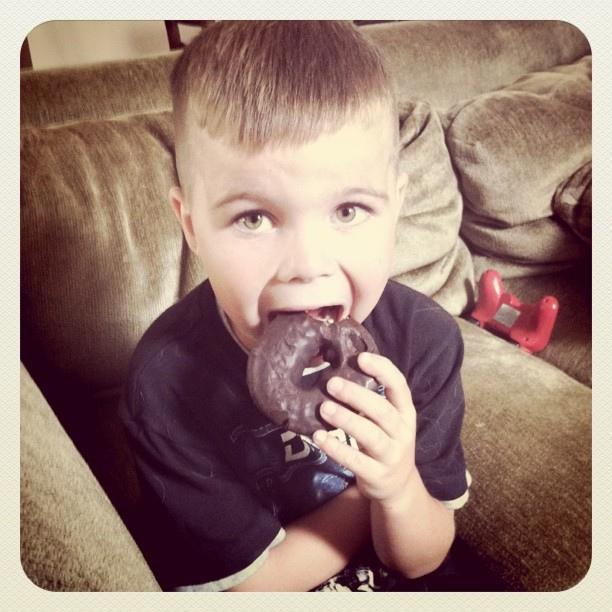How many couches are there?
Give a very brief answer. 2. 